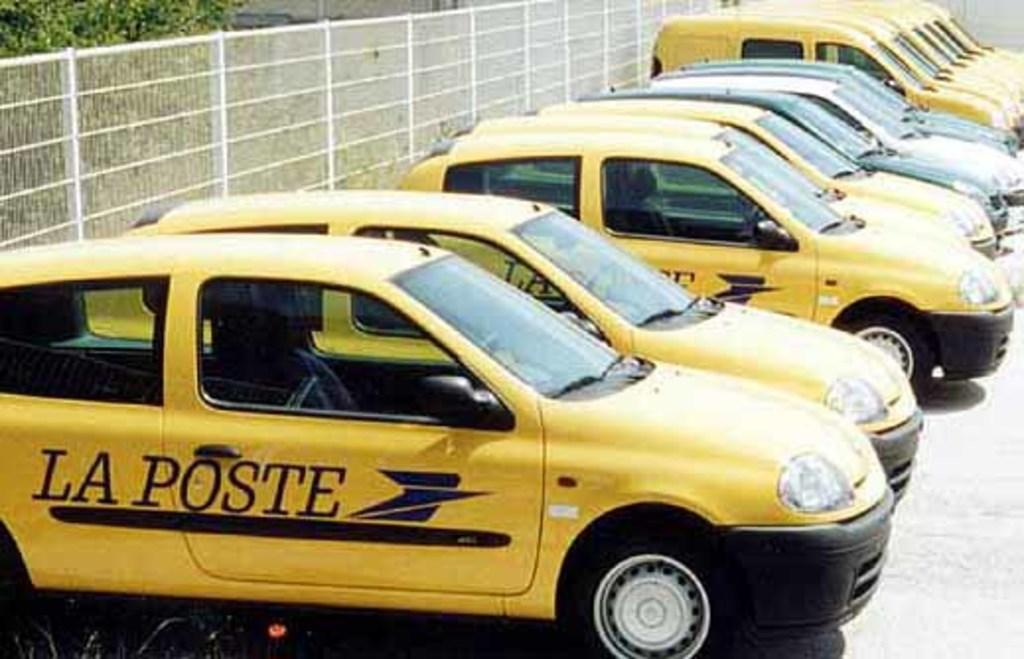<image>
Relay a brief, clear account of the picture shown. Many taxis with the name LA POSTE on the side are parked. 